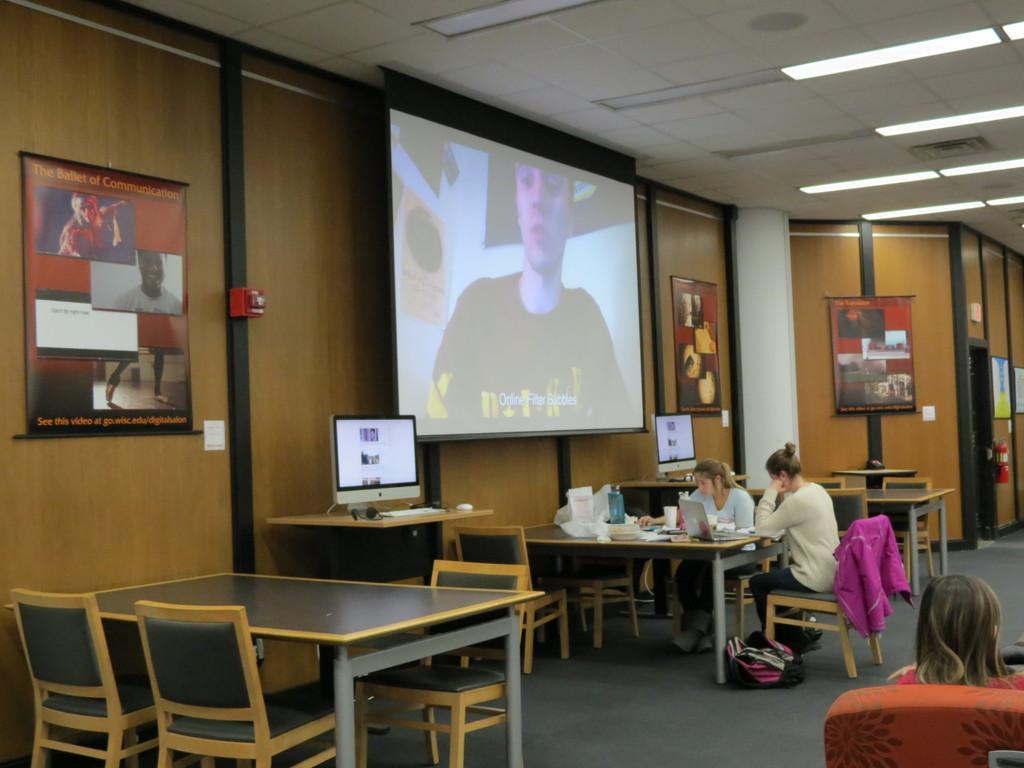Describe this image in one or two sentences. In the image we can see there are table and chairs and there are people who are sitting on the chair and on the wall there is a screen and there are monitors on the table. 